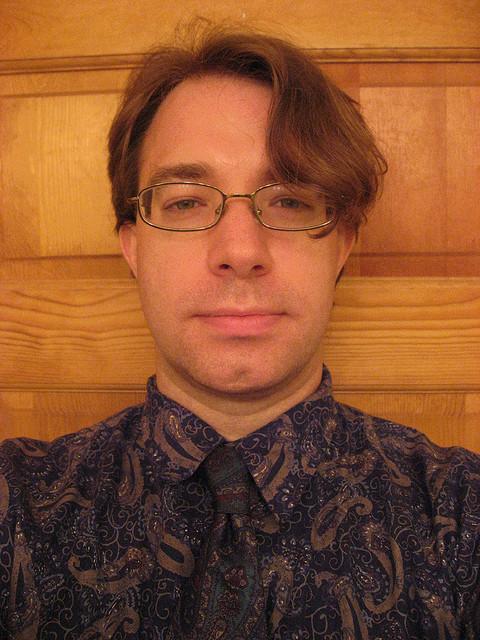Is this photograph most likely a selfie or a portrait captured by another person?
Write a very short answer. Selfie. Whose curtains did he make that shirt from - his aunt or his grandmother?
Keep it brief. Grandmother. What print is on the man's shirt?
Answer briefly. Paisley. 